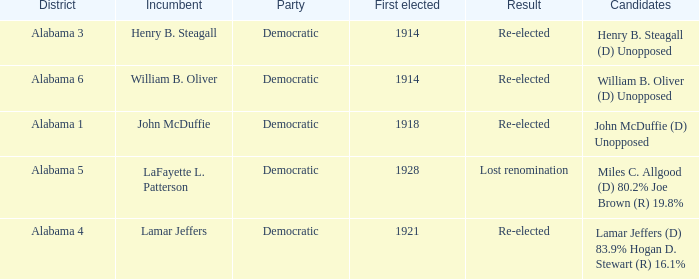Would you be able to parse every entry in this table? {'header': ['District', 'Incumbent', 'Party', 'First elected', 'Result', 'Candidates'], 'rows': [['Alabama 3', 'Henry B. Steagall', 'Democratic', '1914', 'Re-elected', 'Henry B. Steagall (D) Unopposed'], ['Alabama 6', 'William B. Oliver', 'Democratic', '1914', 'Re-elected', 'William B. Oliver (D) Unopposed'], ['Alabama 1', 'John McDuffie', 'Democratic', '1918', 'Re-elected', 'John McDuffie (D) Unopposed'], ['Alabama 5', 'LaFayette L. Patterson', 'Democratic', '1928', 'Lost renomination', 'Miles C. Allgood (D) 80.2% Joe Brown (R) 19.8%'], ['Alabama 4', 'Lamar Jeffers', 'Democratic', '1921', 'Re-elected', 'Lamar Jeffers (D) 83.9% Hogan D. Stewart (R) 16.1%']]} How many in total were elected first in lost renomination? 1.0. 